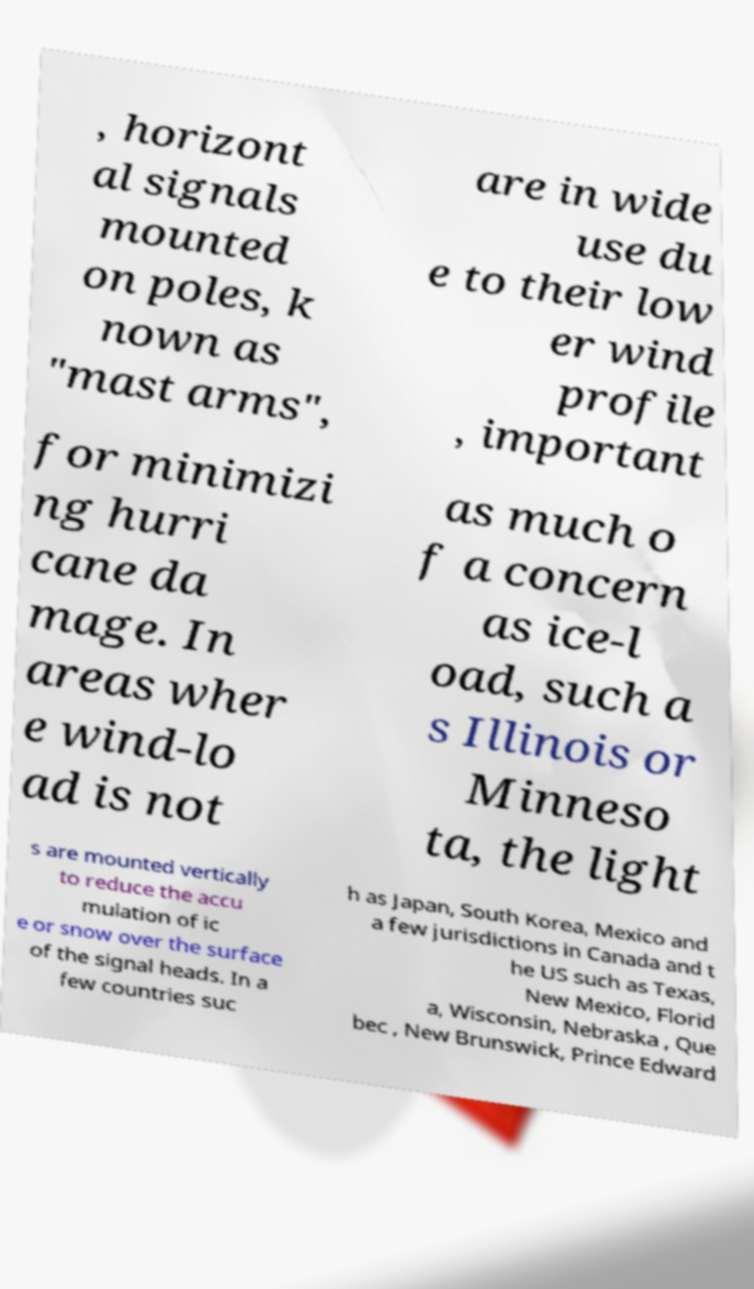I need the written content from this picture converted into text. Can you do that? , horizont al signals mounted on poles, k nown as "mast arms", are in wide use du e to their low er wind profile , important for minimizi ng hurri cane da mage. In areas wher e wind-lo ad is not as much o f a concern as ice-l oad, such a s Illinois or Minneso ta, the light s are mounted vertically to reduce the accu mulation of ic e or snow over the surface of the signal heads. In a few countries suc h as Japan, South Korea, Mexico and a few jurisdictions in Canada and t he US such as Texas, New Mexico, Florid a, Wisconsin, Nebraska , Que bec , New Brunswick, Prince Edward 